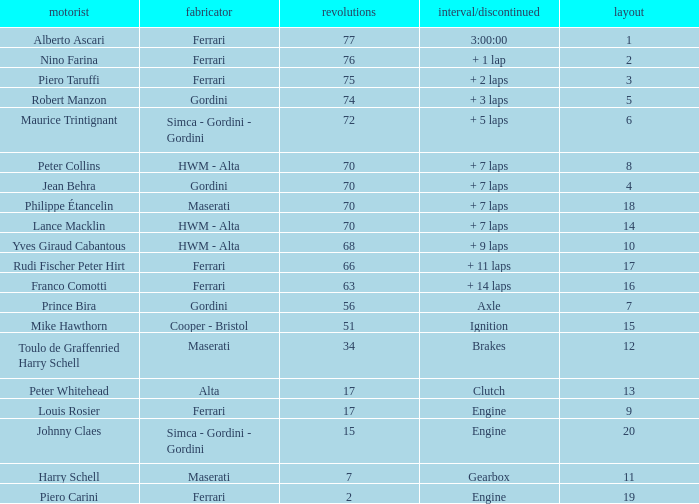How many grids for peter collins? 1.0. 